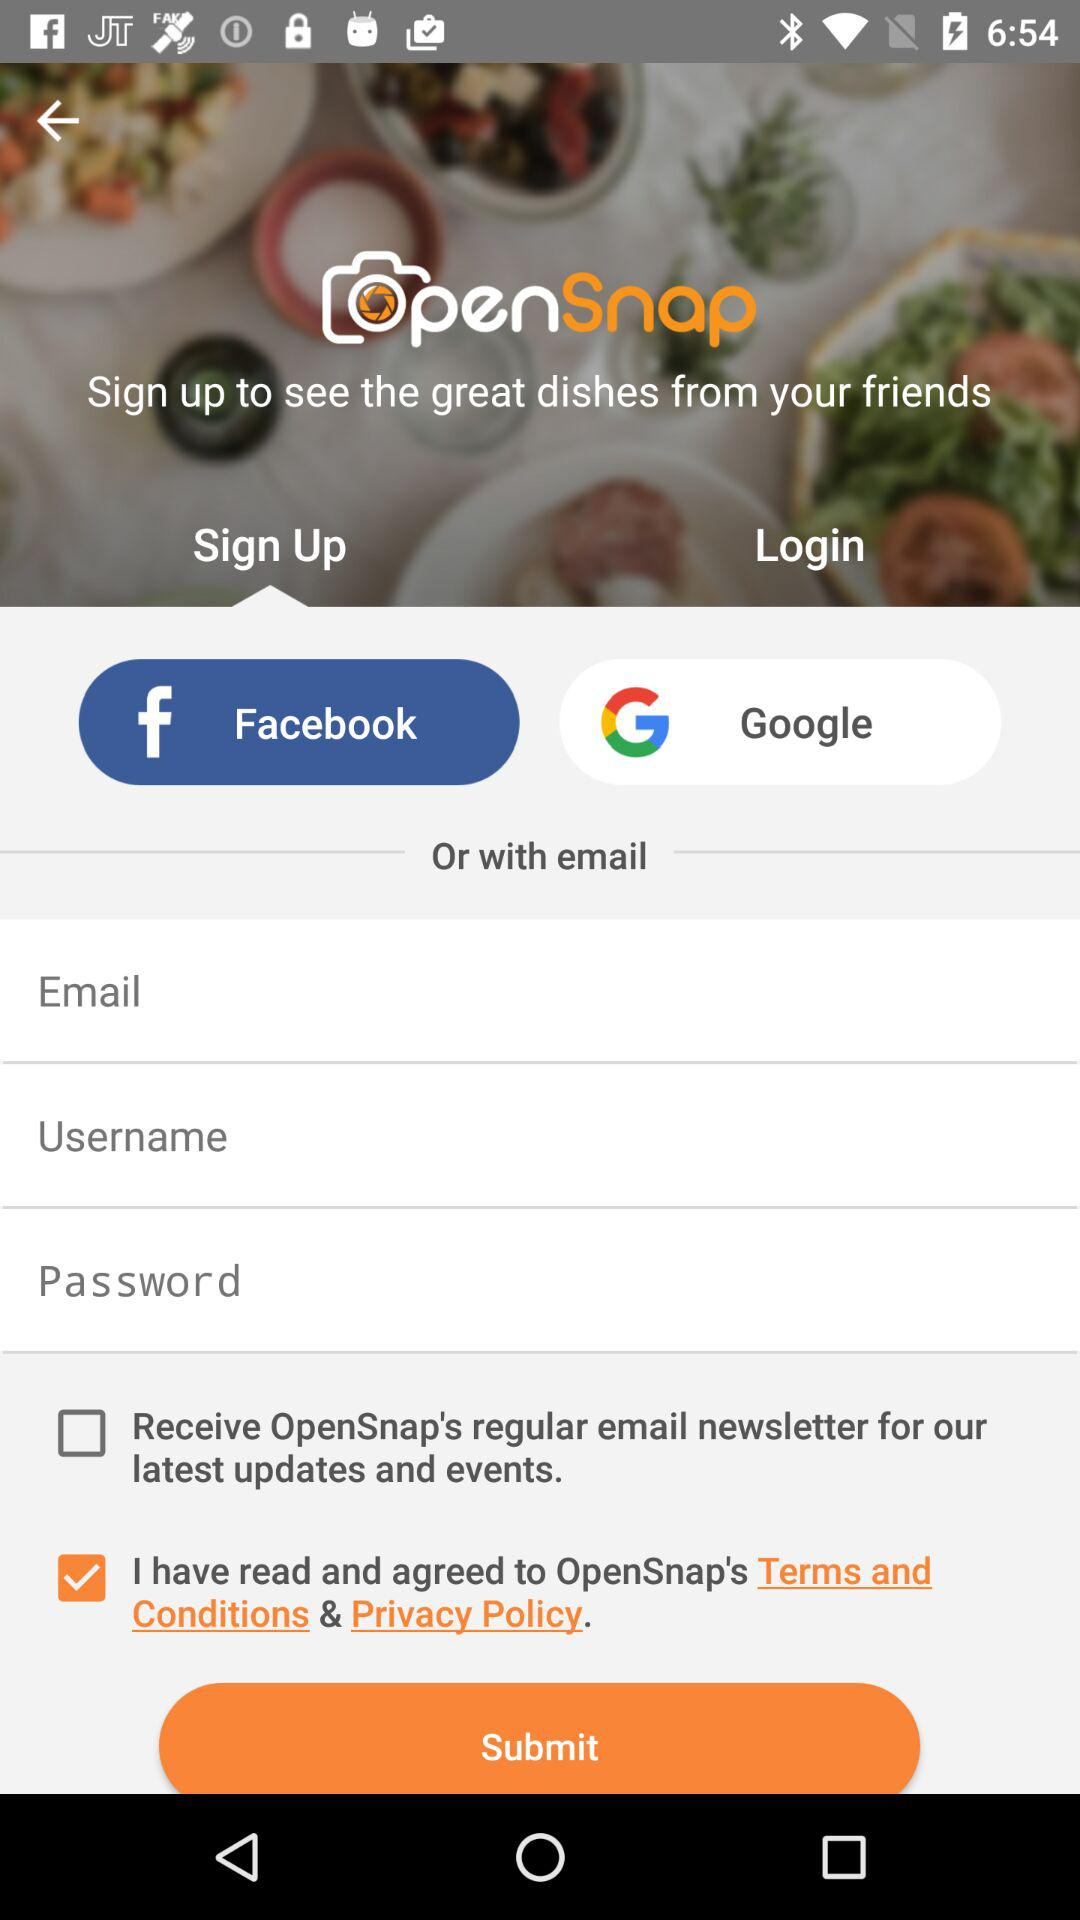Through which application can we sign up? You can sign up through "Facebook" and "Google". 